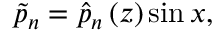Convert formula to latex. <formula><loc_0><loc_0><loc_500><loc_500>\tilde { p } _ { n } = \hat { p } _ { n } \left ( z \right ) \sin { x } ,</formula> 